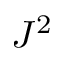Convert formula to latex. <formula><loc_0><loc_0><loc_500><loc_500>J ^ { 2 }</formula> 